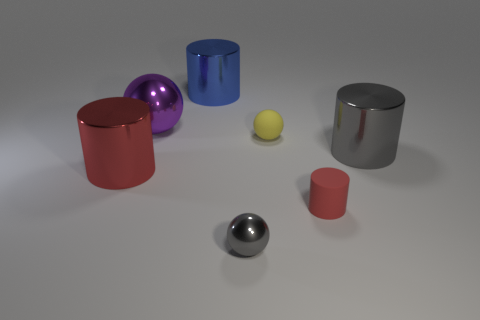What is the red thing that is on the right side of the cylinder on the left side of the large thing that is behind the purple shiny sphere made of?
Offer a very short reply. Rubber. There is a red object that is the same material as the large purple sphere; what size is it?
Make the answer very short. Large. Are there any tiny shiny objects that have the same color as the small matte cylinder?
Give a very brief answer. No. There is a red matte cylinder; is it the same size as the cylinder right of the tiny red thing?
Offer a terse response. No. What number of blue metallic things are right of the metallic cylinder to the left of the thing behind the large shiny sphere?
Ensure brevity in your answer.  1. There is another cylinder that is the same color as the tiny cylinder; what is its size?
Provide a short and direct response. Large. Are there any large shiny balls left of the big sphere?
Give a very brief answer. No. There is a small yellow object; what shape is it?
Give a very brief answer. Sphere. What is the shape of the large thing in front of the gray object that is right of the small matte object that is in front of the tiny yellow sphere?
Make the answer very short. Cylinder. What number of other objects are there of the same shape as the yellow object?
Make the answer very short. 2. 